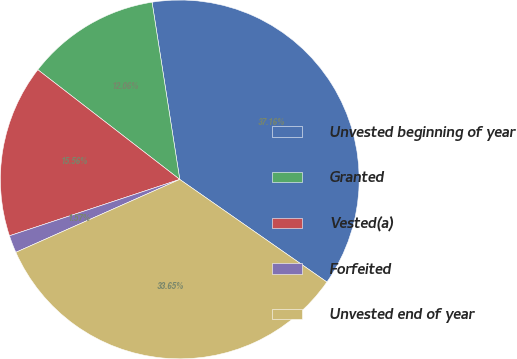<chart> <loc_0><loc_0><loc_500><loc_500><pie_chart><fcel>Unvested beginning of year<fcel>Granted<fcel>Vested(a)<fcel>Forfeited<fcel>Unvested end of year<nl><fcel>37.16%<fcel>12.06%<fcel>15.56%<fcel>1.57%<fcel>33.65%<nl></chart> 